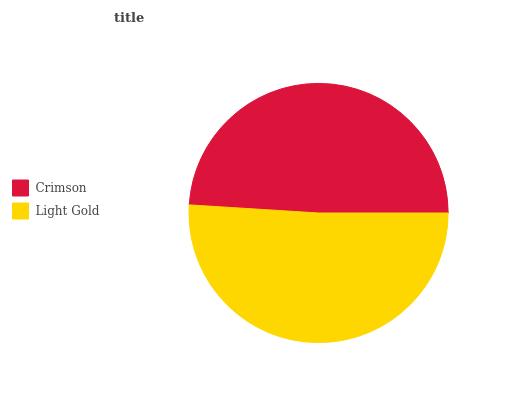Is Crimson the minimum?
Answer yes or no. Yes. Is Light Gold the maximum?
Answer yes or no. Yes. Is Light Gold the minimum?
Answer yes or no. No. Is Light Gold greater than Crimson?
Answer yes or no. Yes. Is Crimson less than Light Gold?
Answer yes or no. Yes. Is Crimson greater than Light Gold?
Answer yes or no. No. Is Light Gold less than Crimson?
Answer yes or no. No. Is Light Gold the high median?
Answer yes or no. Yes. Is Crimson the low median?
Answer yes or no. Yes. Is Crimson the high median?
Answer yes or no. No. Is Light Gold the low median?
Answer yes or no. No. 